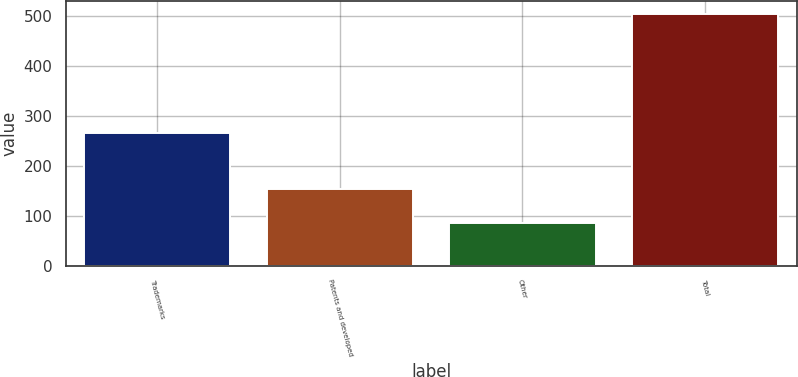Convert chart to OTSL. <chart><loc_0><loc_0><loc_500><loc_500><bar_chart><fcel>Trademarks<fcel>Patents and developed<fcel>Other<fcel>Total<nl><fcel>266<fcel>153<fcel>86<fcel>505<nl></chart> 